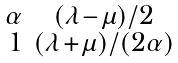Convert formula to latex. <formula><loc_0><loc_0><loc_500><loc_500>\begin{smallmatrix} \alpha & ( \lambda - \mu ) / 2 \\ 1 & ( \lambda + \mu ) / ( 2 \alpha ) \end{smallmatrix}</formula> 